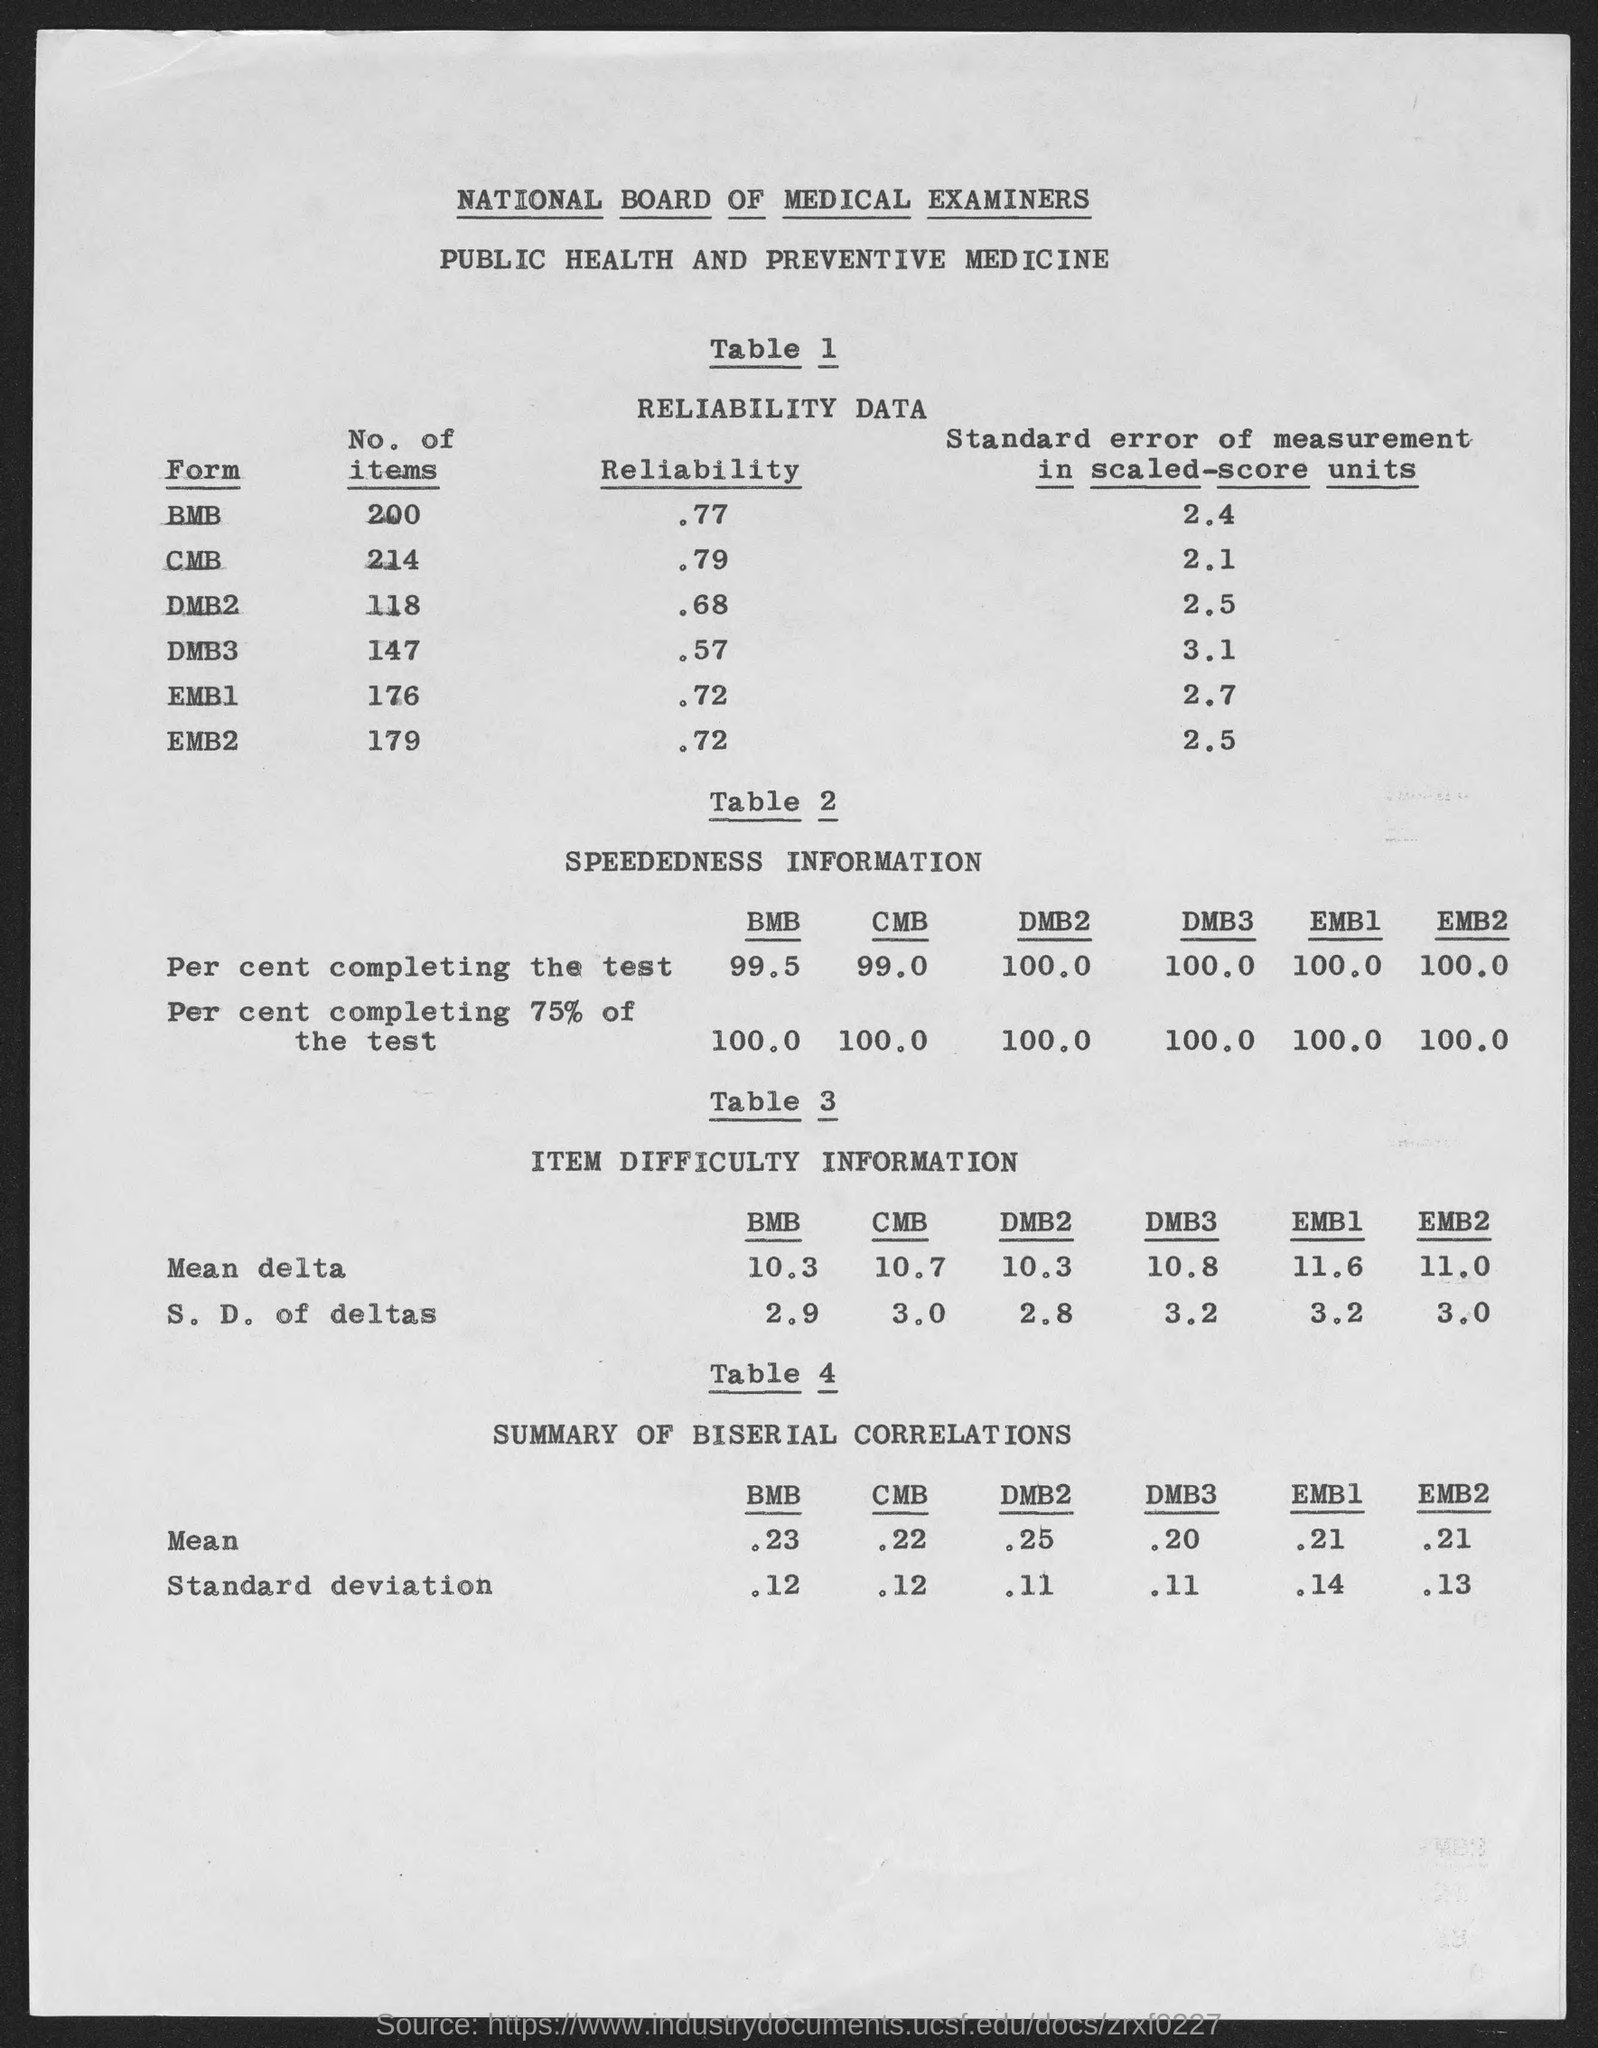What is the title of table 1?
Provide a succinct answer. Reliability Data. What is the title of table 2?
Your answer should be very brief. SPEEDEDNESS  INFORMATION. What is the title of table 3?
Provide a succinct answer. ITEM DIFFICULTY INFORMATION. What is the title of table 4?
Offer a very short reply. Summary of Biserial Correlations. What is the mean value in summary of biserial correlation in bmb column?
Give a very brief answer. .23. What is the standard deviation value in summary of biserial correlation in bmb column?
Keep it short and to the point. .12. What is the mean value in summary of biserial correlation in cmb column?
Ensure brevity in your answer.  .22. What is the standard deviation value in summary of biserial correlation in cmb column?
Make the answer very short. .12. What is the mean value in summary of biserial correlation in dmb2 column?
Give a very brief answer. .25. What is the standard deviation value in summary of biserial correlation in dmb2 column?
Provide a succinct answer. .11. 